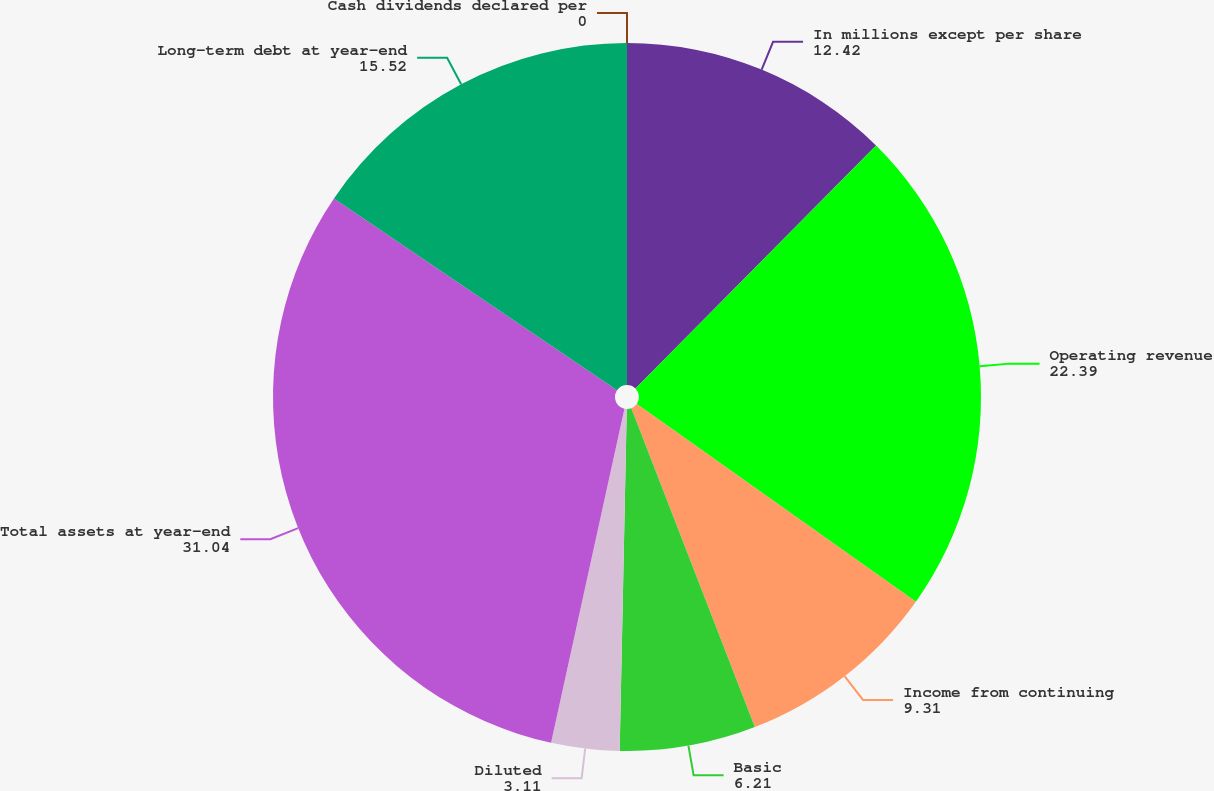<chart> <loc_0><loc_0><loc_500><loc_500><pie_chart><fcel>In millions except per share<fcel>Operating revenue<fcel>Income from continuing<fcel>Basic<fcel>Diluted<fcel>Total assets at year-end<fcel>Long-term debt at year-end<fcel>Cash dividends declared per<nl><fcel>12.42%<fcel>22.39%<fcel>9.31%<fcel>6.21%<fcel>3.11%<fcel>31.04%<fcel>15.52%<fcel>0.0%<nl></chart> 